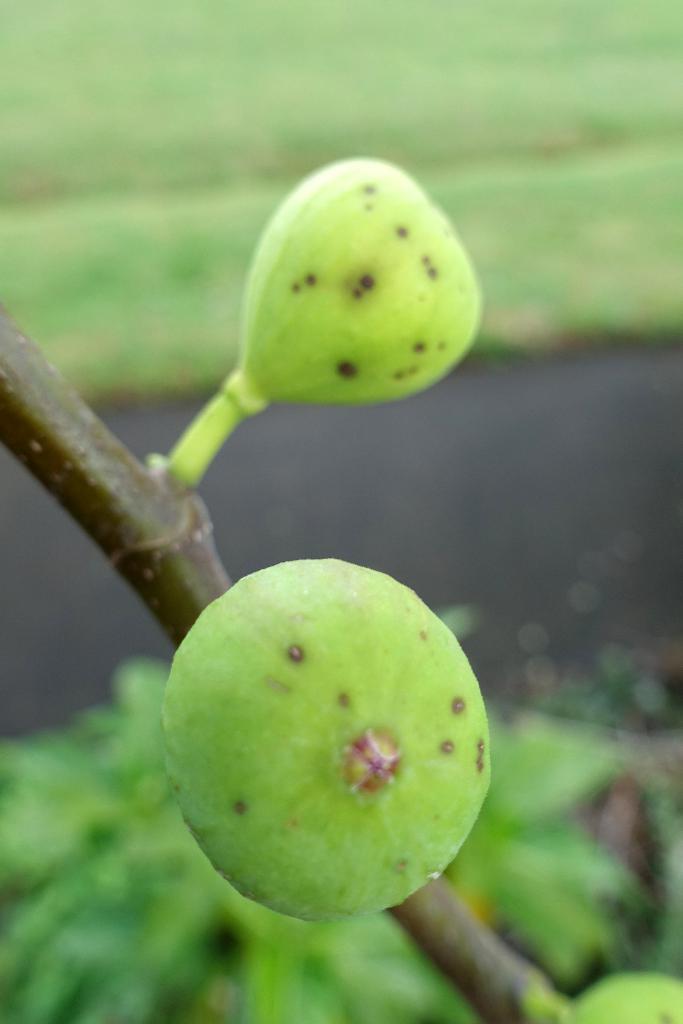Please provide a concise description of this image. In this picture we can see fruits and in the background we can see plants, some objects and it is blurry. 